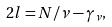<formula> <loc_0><loc_0><loc_500><loc_500>2 l = N / \nu - \gamma _ { \nu } ,</formula> 